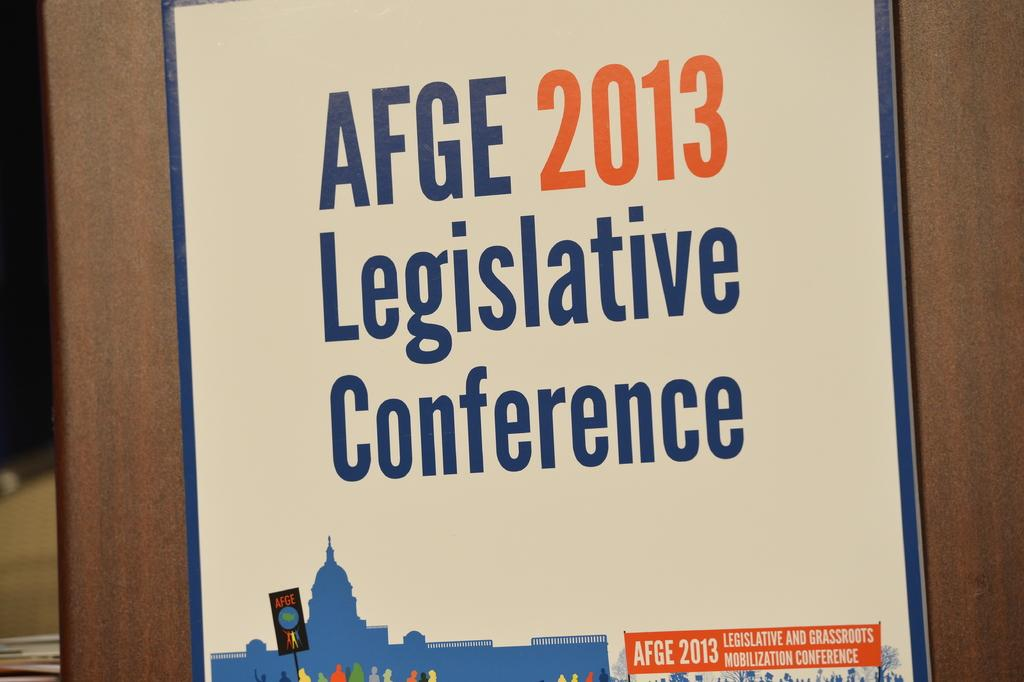What is the main object in the image? There is a frame in the image. What is featured in the center of the frame? There is text written in the center of the frame. Where is the protest taking place in the image? There is no protest present in the image; it only features a frame with text in the center. 